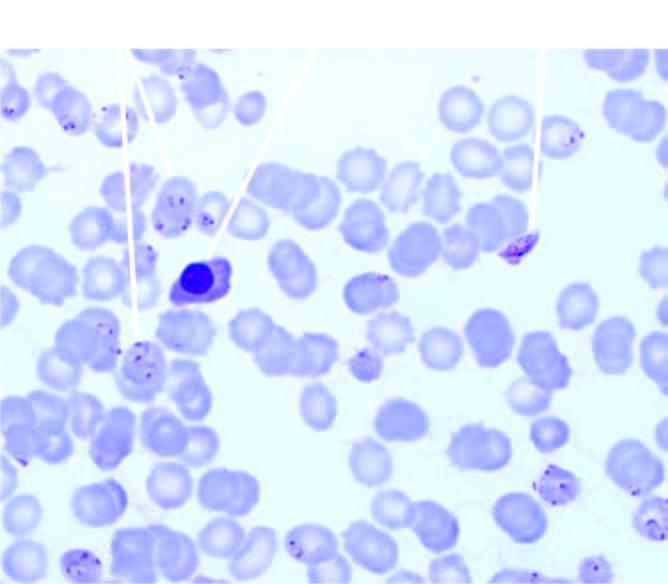what shows a normoblast?
Answer the question using a single word or phrase. The background 